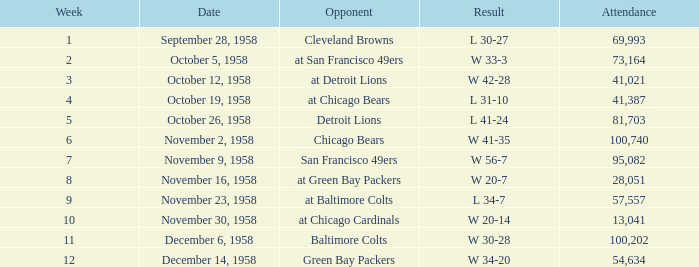On november 9, 1958, what was the maximum number of attendees? 95082.0. 